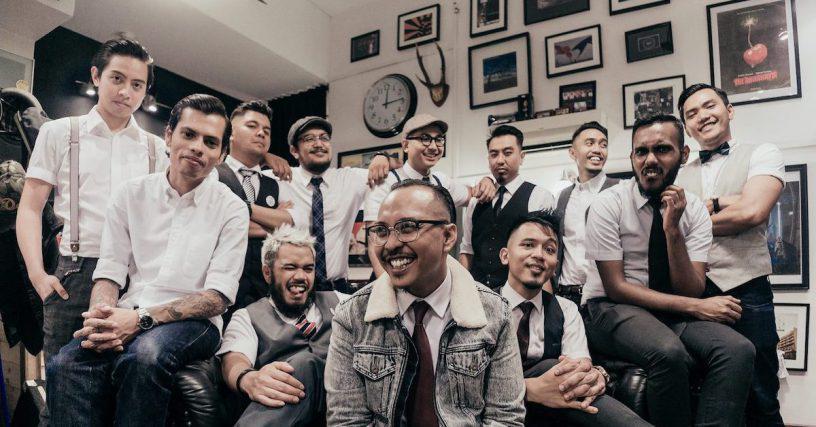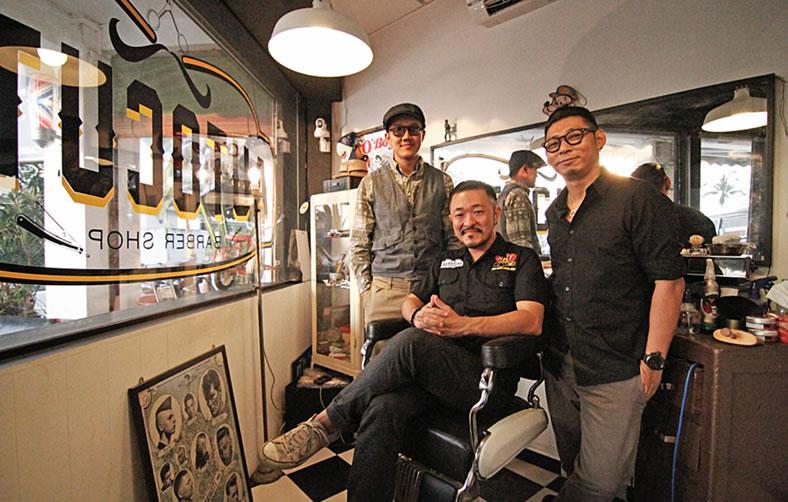The first image is the image on the left, the second image is the image on the right. Evaluate the accuracy of this statement regarding the images: "There are more than four people.". Is it true? Answer yes or no. Yes. The first image is the image on the left, the second image is the image on the right. For the images shown, is this caption "There are no more than four people in the barber shop." true? Answer yes or no. No. 